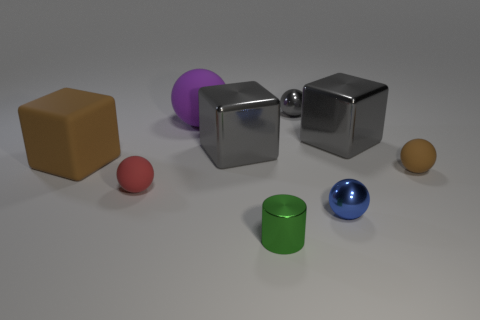Add 1 gray metal balls. How many objects exist? 10 Subtract all gray cylinders. How many gray blocks are left? 2 Subtract all red spheres. How many spheres are left? 4 Subtract all big gray cubes. How many cubes are left? 1 Subtract 4 spheres. How many spheres are left? 1 Subtract all brown spheres. Subtract all brown cylinders. How many spheres are left? 4 Subtract all spheres. How many objects are left? 4 Add 1 big cyan matte cylinders. How many big cyan matte cylinders exist? 1 Subtract 1 brown cubes. How many objects are left? 8 Subtract all brown objects. Subtract all tiny blue objects. How many objects are left? 6 